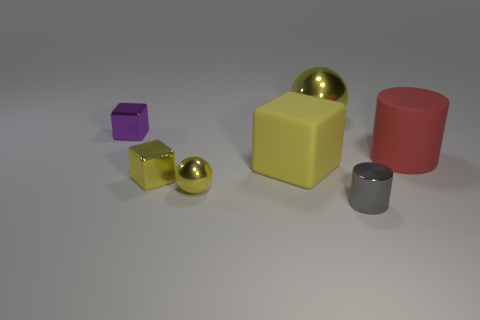What is the color of the sphere that is the same size as the matte cylinder?
Give a very brief answer. Yellow. How many other things are the same shape as the large yellow shiny object?
Make the answer very short. 1. Are there any large green blocks made of the same material as the large red cylinder?
Give a very brief answer. No. Does the tiny cube in front of the large yellow rubber block have the same material as the large object to the left of the big shiny thing?
Your answer should be compact. No. What number of tiny cyan rubber cubes are there?
Your answer should be very brief. 0. There is a large object that is behind the big red object; what is its shape?
Provide a succinct answer. Sphere. What number of other objects are the same size as the red thing?
Ensure brevity in your answer.  2. Do the large yellow thing that is in front of the small purple block and the big thing that is to the right of the tiny gray cylinder have the same shape?
Provide a succinct answer. No. There is a gray thing; what number of red matte objects are on the right side of it?
Provide a succinct answer. 1. What is the color of the small block on the right side of the tiny purple cube?
Provide a succinct answer. Yellow. 